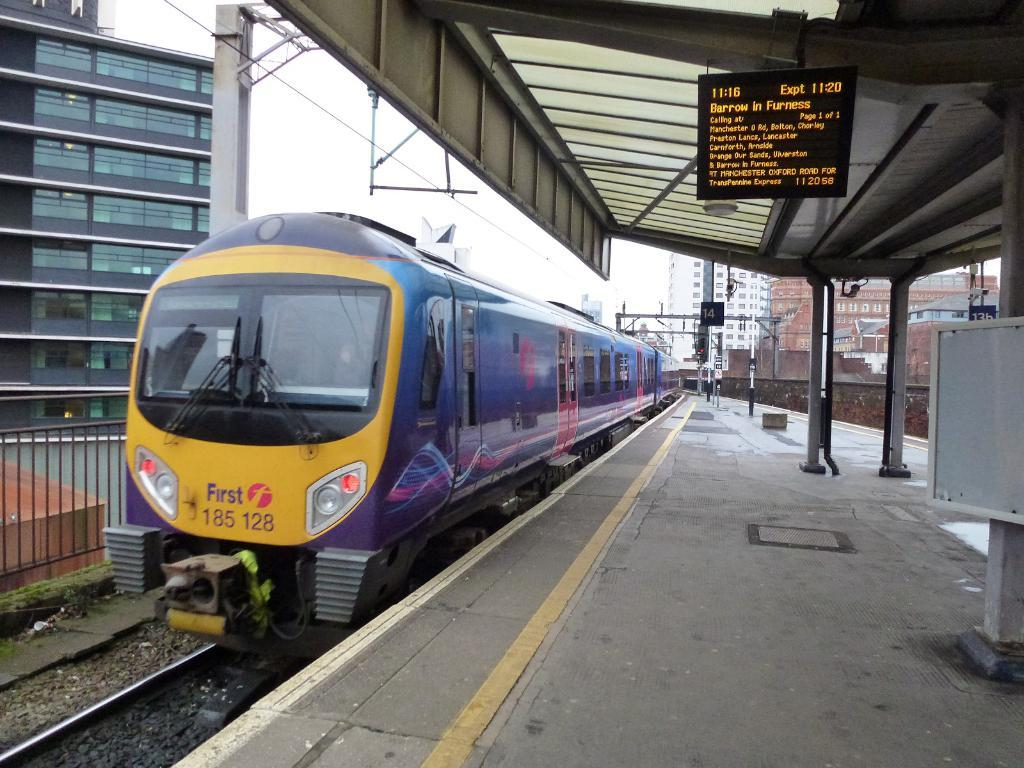<image>
Give a short and clear explanation of the subsequent image. Train number 185 128 arrives at the station. 